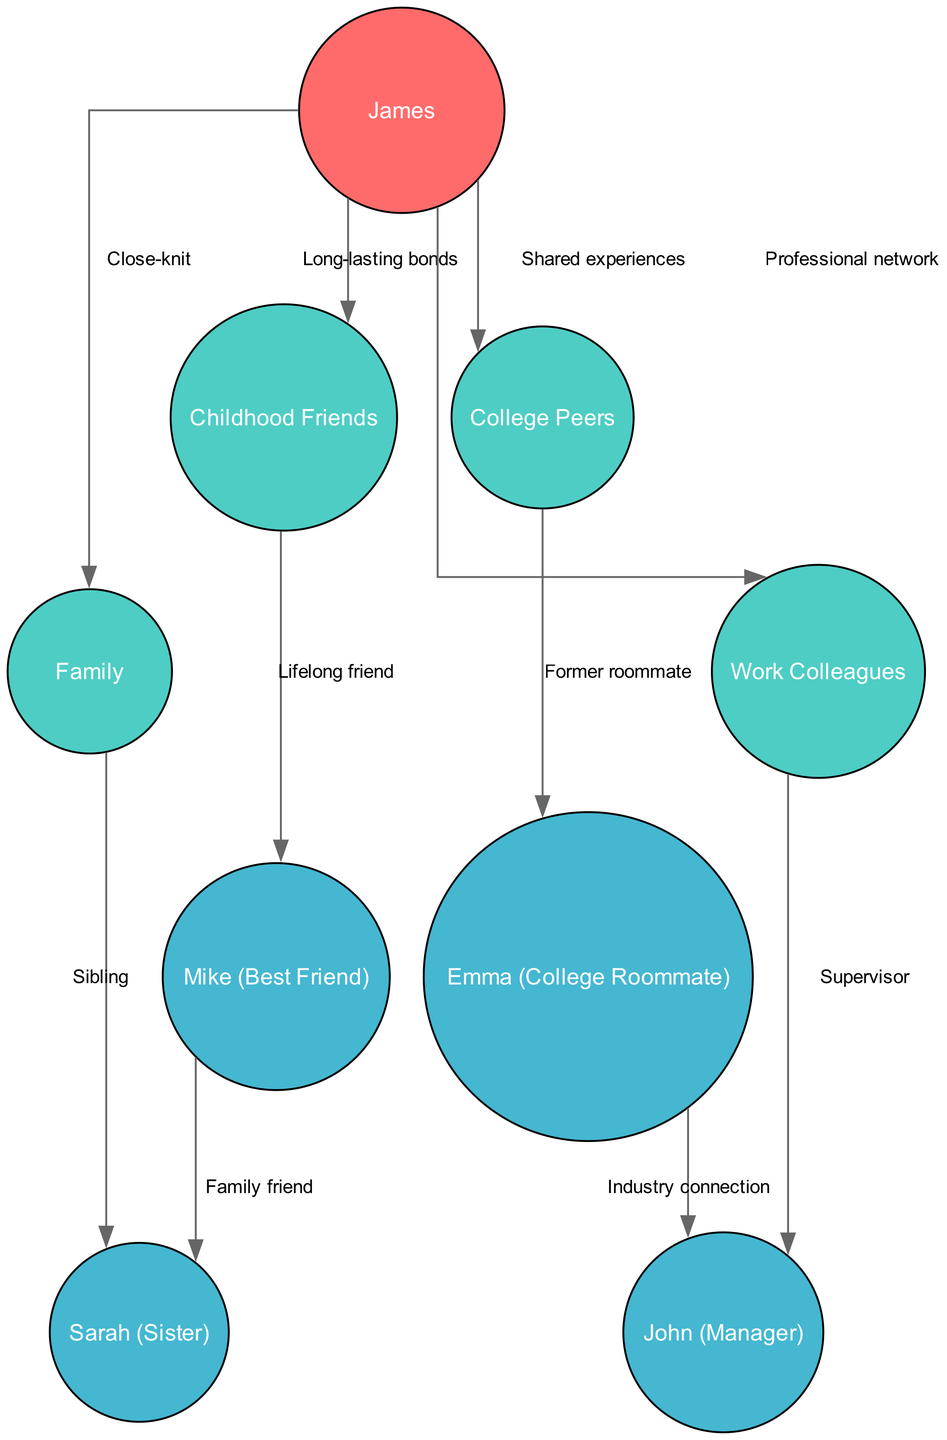What is the central node in the diagram? The central node is identified as "James," who appears at the core of the network, indicating his position as the main individual connecting various social circles.
Answer: James How many primary nodes are present? The primary nodes include "Family," "Childhood Friends," "College Peers," and "Work Colleagues," totaling four distinct groups that connect to James.
Answer: 4 What type of relationship connects James and his sister? The relationship is specified as "Close-knit," which indicates a strong, supportive bond between James and his family.
Answer: Close-knit Who is identified as James's best friend? The node labeled "Mike (Best Friend)" is directly connected to "James" and represents a significant friendship in his social network.
Answer: Mike (Best Friend) Which secondary node is connected to "Emma (College Roommate)"? The secondary connection leads to "John (Manager)," demonstrating a professional relationship stemming from college ties.
Answer: John (Manager) What is the label of the relationship between "Childhood Friends" and "Mike (Best Friend)"? The relationship is labeled as "Lifelong friend," showcasing a deep-rooted friendship originating from childhood experiences.
Answer: Lifelong friend How many edges are there connected to James? There are four edges connecting to James, representing relationships with each of his primary social groups.
Answer: 4 What type of connection exists between "Work Colleagues" and "John (Manager)"? The connection is defined as "Supervisor," indicating John's role in a managerial capacity over James's work relationships.
Answer: Supervisor Which group is indicated as a family connection for Mike? The group labeled "Family" connects to "Sarah (Sister)," illustrating the familial ties between Mike and James's sister.
Answer: Family 